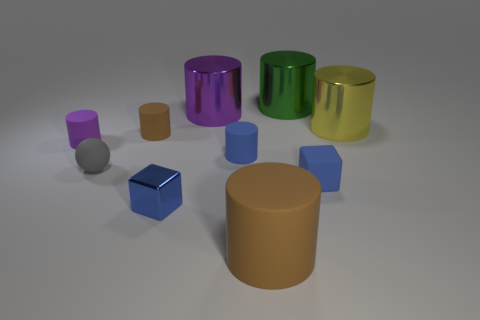Are there more small matte cubes on the right side of the rubber ball than small gray spheres that are on the right side of the purple metallic object?
Your response must be concise. Yes. What shape is the blue matte object right of the brown matte cylinder that is in front of the blue matte thing that is behind the gray thing?
Provide a succinct answer. Cube. What shape is the shiny thing in front of the metallic object to the right of the big green metal cylinder?
Provide a short and direct response. Cube. Are there any green cylinders made of the same material as the large brown thing?
Provide a succinct answer. No. There is a matte object that is the same color as the rubber cube; what size is it?
Provide a succinct answer. Small. What number of cyan things are large matte things or small rubber spheres?
Your response must be concise. 0. Are there any things that have the same color as the big rubber cylinder?
Make the answer very short. Yes. The purple cylinder that is the same material as the yellow object is what size?
Your response must be concise. Large. What number of spheres are either blue objects or blue rubber objects?
Provide a short and direct response. 0. Is the number of small blue metallic things greater than the number of cyan cylinders?
Provide a short and direct response. Yes. 